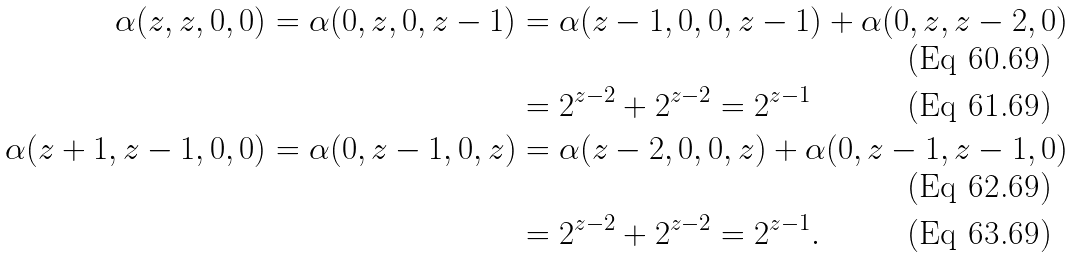Convert formula to latex. <formula><loc_0><loc_0><loc_500><loc_500>\alpha ( z , z , 0 , 0 ) = \alpha ( 0 , z , 0 , z - 1 ) & = \alpha ( z - 1 , 0 , 0 , z - 1 ) + \alpha ( 0 , z , z - 2 , 0 ) \\ & = 2 ^ { z - 2 } + 2 ^ { z - 2 } = 2 ^ { z - 1 } \\ \alpha ( z + 1 , z - 1 , 0 , 0 ) = \alpha ( 0 , z - 1 , 0 , z ) & = \alpha ( z - 2 , 0 , 0 , z ) + \alpha ( 0 , z - 1 , z - 1 , 0 ) \\ & = 2 ^ { z - 2 } + 2 ^ { z - 2 } = 2 ^ { z - 1 } .</formula> 